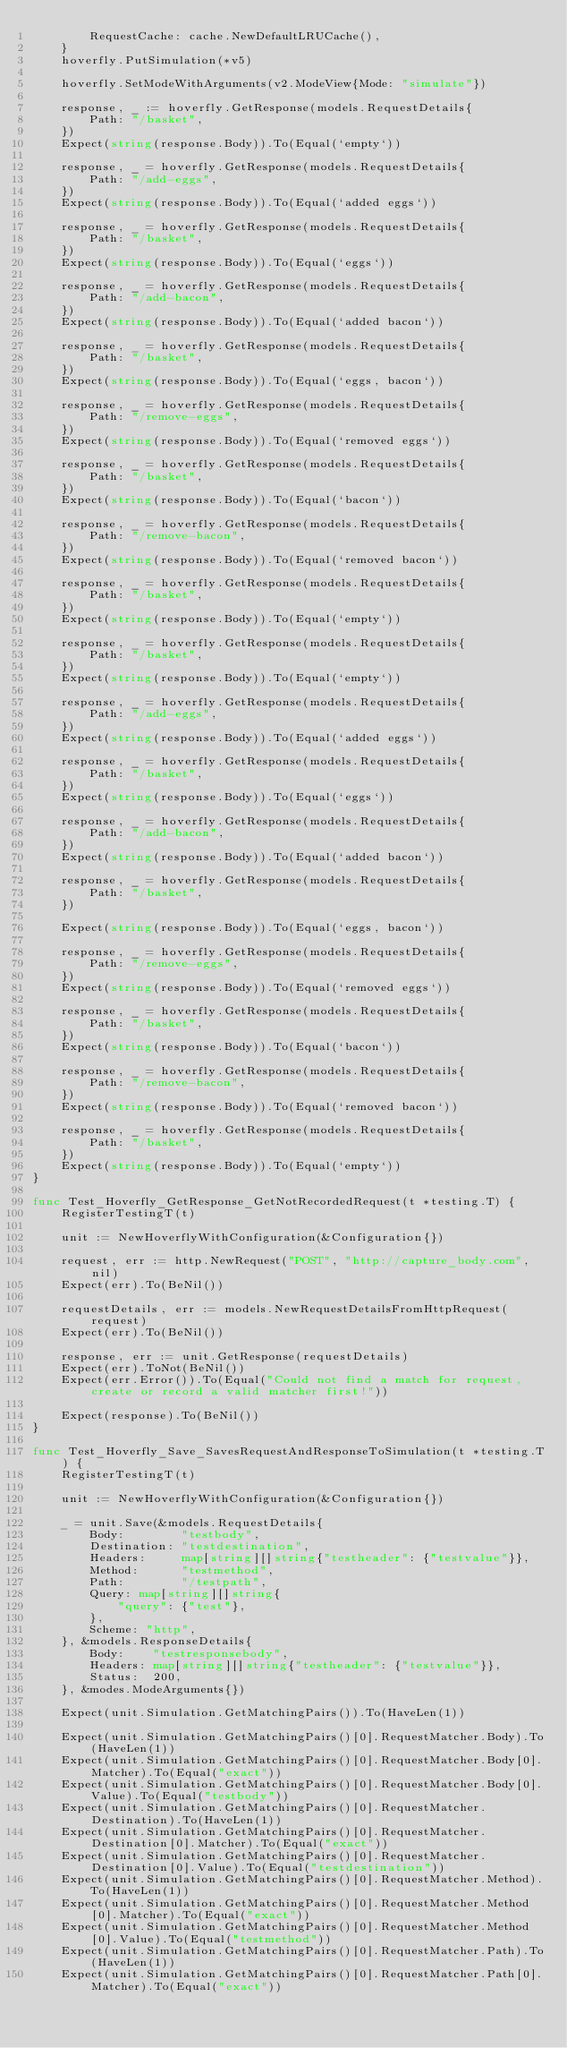Convert code to text. <code><loc_0><loc_0><loc_500><loc_500><_Go_>		RequestCache: cache.NewDefaultLRUCache(),
	}
	hoverfly.PutSimulation(*v5)

	hoverfly.SetModeWithArguments(v2.ModeView{Mode: "simulate"})

	response, _ := hoverfly.GetResponse(models.RequestDetails{
		Path: "/basket",
	})
	Expect(string(response.Body)).To(Equal(`empty`))

	response, _ = hoverfly.GetResponse(models.RequestDetails{
		Path: "/add-eggs",
	})
	Expect(string(response.Body)).To(Equal(`added eggs`))

	response, _ = hoverfly.GetResponse(models.RequestDetails{
		Path: "/basket",
	})
	Expect(string(response.Body)).To(Equal(`eggs`))

	response, _ = hoverfly.GetResponse(models.RequestDetails{
		Path: "/add-bacon",
	})
	Expect(string(response.Body)).To(Equal(`added bacon`))

	response, _ = hoverfly.GetResponse(models.RequestDetails{
		Path: "/basket",
	})
	Expect(string(response.Body)).To(Equal(`eggs, bacon`))

	response, _ = hoverfly.GetResponse(models.RequestDetails{
		Path: "/remove-eggs",
	})
	Expect(string(response.Body)).To(Equal(`removed eggs`))

	response, _ = hoverfly.GetResponse(models.RequestDetails{
		Path: "/basket",
	})
	Expect(string(response.Body)).To(Equal(`bacon`))

	response, _ = hoverfly.GetResponse(models.RequestDetails{
		Path: "/remove-bacon",
	})
	Expect(string(response.Body)).To(Equal(`removed bacon`))

	response, _ = hoverfly.GetResponse(models.RequestDetails{
		Path: "/basket",
	})
	Expect(string(response.Body)).To(Equal(`empty`))

	response, _ = hoverfly.GetResponse(models.RequestDetails{
		Path: "/basket",
	})
	Expect(string(response.Body)).To(Equal(`empty`))

	response, _ = hoverfly.GetResponse(models.RequestDetails{
		Path: "/add-eggs",
	})
	Expect(string(response.Body)).To(Equal(`added eggs`))

	response, _ = hoverfly.GetResponse(models.RequestDetails{
		Path: "/basket",
	})
	Expect(string(response.Body)).To(Equal(`eggs`))

	response, _ = hoverfly.GetResponse(models.RequestDetails{
		Path: "/add-bacon",
	})
	Expect(string(response.Body)).To(Equal(`added bacon`))

	response, _ = hoverfly.GetResponse(models.RequestDetails{
		Path: "/basket",
	})

	Expect(string(response.Body)).To(Equal(`eggs, bacon`))

	response, _ = hoverfly.GetResponse(models.RequestDetails{
		Path: "/remove-eggs",
	})
	Expect(string(response.Body)).To(Equal(`removed eggs`))

	response, _ = hoverfly.GetResponse(models.RequestDetails{
		Path: "/basket",
	})
	Expect(string(response.Body)).To(Equal(`bacon`))

	response, _ = hoverfly.GetResponse(models.RequestDetails{
		Path: "/remove-bacon",
	})
	Expect(string(response.Body)).To(Equal(`removed bacon`))

	response, _ = hoverfly.GetResponse(models.RequestDetails{
		Path: "/basket",
	})
	Expect(string(response.Body)).To(Equal(`empty`))
}

func Test_Hoverfly_GetResponse_GetNotRecordedRequest(t *testing.T) {
	RegisterTestingT(t)

	unit := NewHoverflyWithConfiguration(&Configuration{})

	request, err := http.NewRequest("POST", "http://capture_body.com", nil)
	Expect(err).To(BeNil())

	requestDetails, err := models.NewRequestDetailsFromHttpRequest(request)
	Expect(err).To(BeNil())

	response, err := unit.GetResponse(requestDetails)
	Expect(err).ToNot(BeNil())
	Expect(err.Error()).To(Equal("Could not find a match for request, create or record a valid matcher first!"))

	Expect(response).To(BeNil())
}

func Test_Hoverfly_Save_SavesRequestAndResponseToSimulation(t *testing.T) {
	RegisterTestingT(t)

	unit := NewHoverflyWithConfiguration(&Configuration{})

	_ = unit.Save(&models.RequestDetails{
		Body:        "testbody",
		Destination: "testdestination",
		Headers:     map[string][]string{"testheader": {"testvalue"}},
		Method:      "testmethod",
		Path:        "/testpath",
		Query: map[string][]string{
			"query": {"test"},
		},
		Scheme: "http",
	}, &models.ResponseDetails{
		Body:    "testresponsebody",
		Headers: map[string][]string{"testheader": {"testvalue"}},
		Status:  200,
	}, &modes.ModeArguments{})

	Expect(unit.Simulation.GetMatchingPairs()).To(HaveLen(1))

	Expect(unit.Simulation.GetMatchingPairs()[0].RequestMatcher.Body).To(HaveLen(1))
	Expect(unit.Simulation.GetMatchingPairs()[0].RequestMatcher.Body[0].Matcher).To(Equal("exact"))
	Expect(unit.Simulation.GetMatchingPairs()[0].RequestMatcher.Body[0].Value).To(Equal("testbody"))
	Expect(unit.Simulation.GetMatchingPairs()[0].RequestMatcher.Destination).To(HaveLen(1))
	Expect(unit.Simulation.GetMatchingPairs()[0].RequestMatcher.Destination[0].Matcher).To(Equal("exact"))
	Expect(unit.Simulation.GetMatchingPairs()[0].RequestMatcher.Destination[0].Value).To(Equal("testdestination"))
	Expect(unit.Simulation.GetMatchingPairs()[0].RequestMatcher.Method).To(HaveLen(1))
	Expect(unit.Simulation.GetMatchingPairs()[0].RequestMatcher.Method[0].Matcher).To(Equal("exact"))
	Expect(unit.Simulation.GetMatchingPairs()[0].RequestMatcher.Method[0].Value).To(Equal("testmethod"))
	Expect(unit.Simulation.GetMatchingPairs()[0].RequestMatcher.Path).To(HaveLen(1))
	Expect(unit.Simulation.GetMatchingPairs()[0].RequestMatcher.Path[0].Matcher).To(Equal("exact"))</code> 